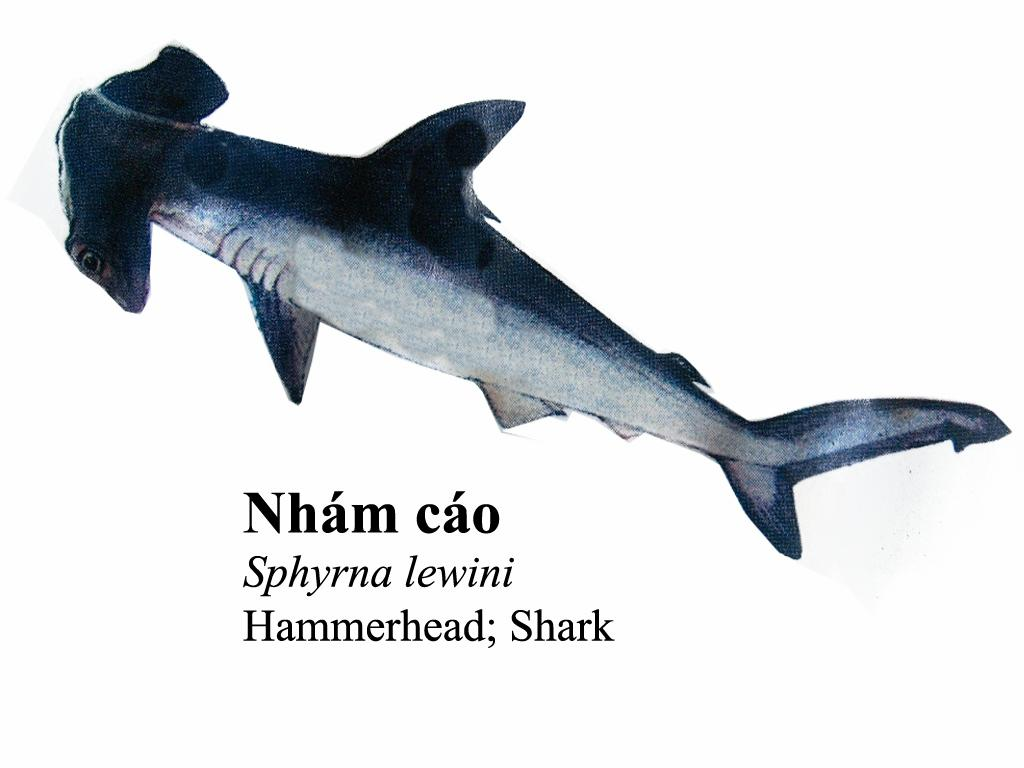What is the main subject of the image? The main subject of the image is an image of a shark. Can you describe any other elements in the image? Yes, there is text present in the image. How does the shark increase its speed in the image? The image does not depict the shark moving or changing its speed; it is a static image of a shark. What type of plants can be seen growing near the shark in the image? There are no plants visible in the image; it only features an image of a shark and text. 